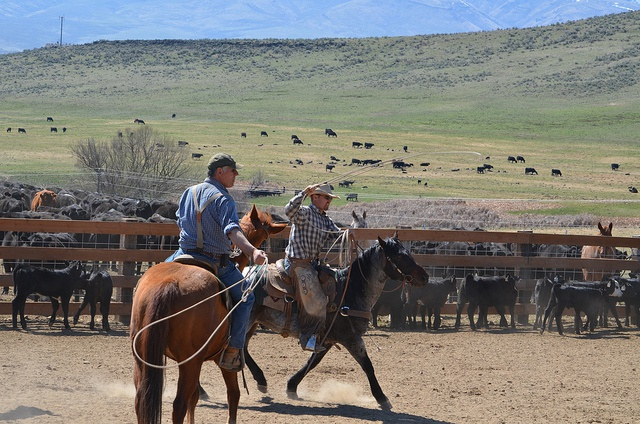Describe the objects in this image and their specific colors. I can see horse in lightblue, black, maroon, and gray tones, horse in lightblue, black, gray, and darkgray tones, people in lightblue, black, navy, gray, and darkblue tones, people in lightblue, gray, black, maroon, and darkgray tones, and cow in lightblue, black, gray, and darkgray tones in this image. 